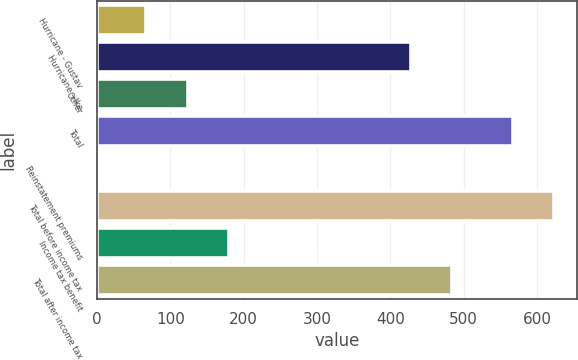Convert chart to OTSL. <chart><loc_0><loc_0><loc_500><loc_500><bar_chart><fcel>Hurricane - Gustav<fcel>Hurricane - Ike<fcel>Other<fcel>Total<fcel>Reinstatement premiums<fcel>Total before income tax<fcel>Income tax benefit<fcel>Total after income tax<nl><fcel>67<fcel>428<fcel>123.7<fcel>567<fcel>3<fcel>623.7<fcel>180.4<fcel>484.7<nl></chart> 